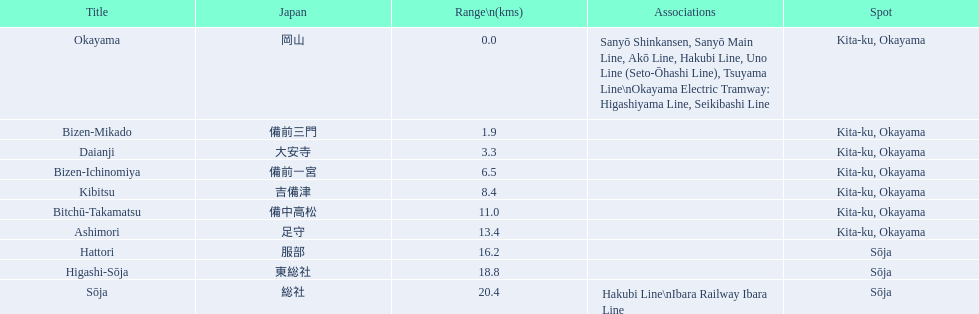What are all of the train names? Okayama, Bizen-Mikado, Daianji, Bizen-Ichinomiya, Kibitsu, Bitchū-Takamatsu, Ashimori, Hattori, Higashi-Sōja, Sōja. What is the distance for each? 0.0, 1.9, 3.3, 6.5, 8.4, 11.0, 13.4, 16.2, 18.8, 20.4. And which train's distance is between 1 and 2 km? Bizen-Mikado. 